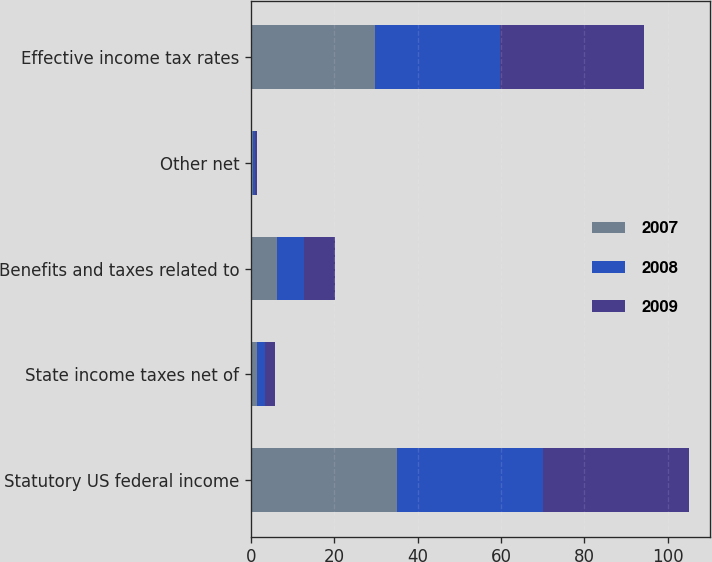<chart> <loc_0><loc_0><loc_500><loc_500><stacked_bar_chart><ecel><fcel>Statutory US federal income<fcel>State income taxes net of<fcel>Benefits and taxes related to<fcel>Other net<fcel>Effective income tax rates<nl><fcel>2007<fcel>35<fcel>1.6<fcel>6.3<fcel>0.5<fcel>29.8<nl><fcel>2008<fcel>35<fcel>1.8<fcel>6.4<fcel>0.4<fcel>30<nl><fcel>2009<fcel>35<fcel>2.3<fcel>7.5<fcel>0.6<fcel>34.6<nl></chart> 